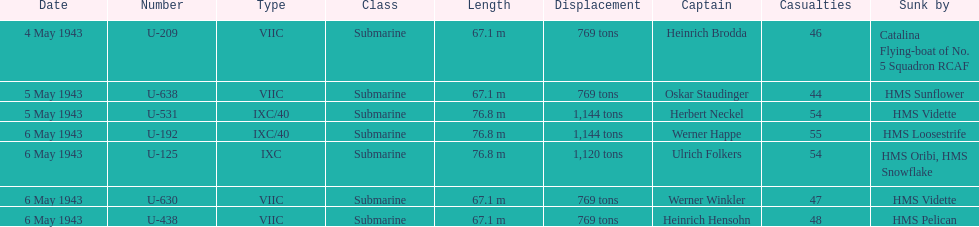Which date had at least 55 casualties? 6 May 1943. 